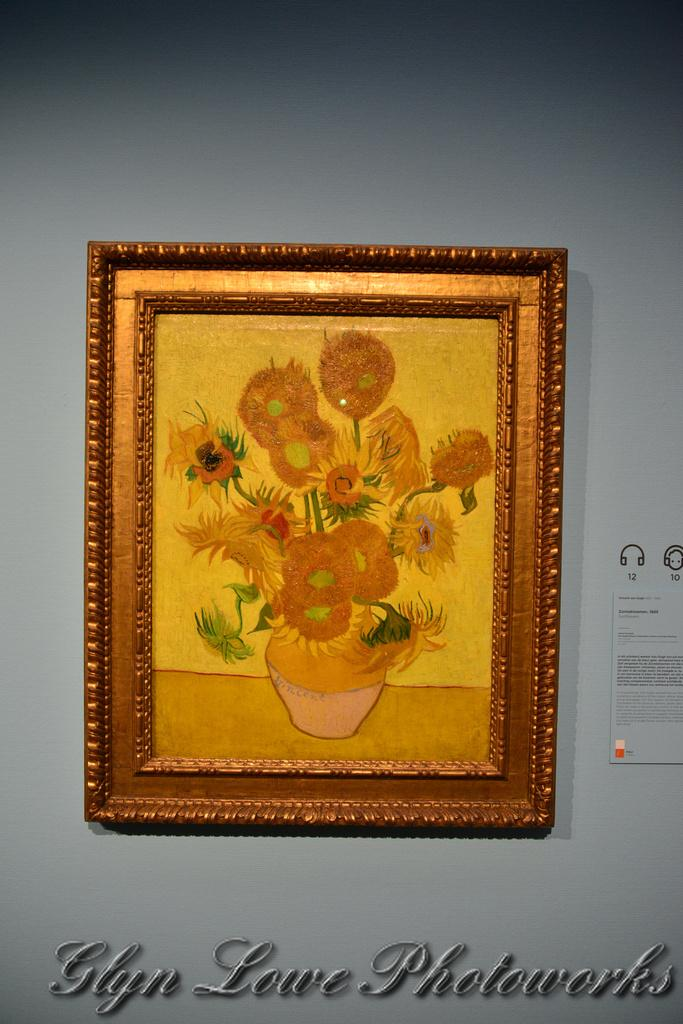What object can be seen in the image that typically holds a photograph? There is a photo frame in the image. What type of decoration is on the wall in the image? There is a poster on the wall in the image. What can be read or seen at the bottom of the image? There is text visible at the bottom of the image. What type of hospital equipment can be seen in the image? There is no hospital equipment present in the image. What type of destruction is visible in the image? There is no destruction present in the image. 